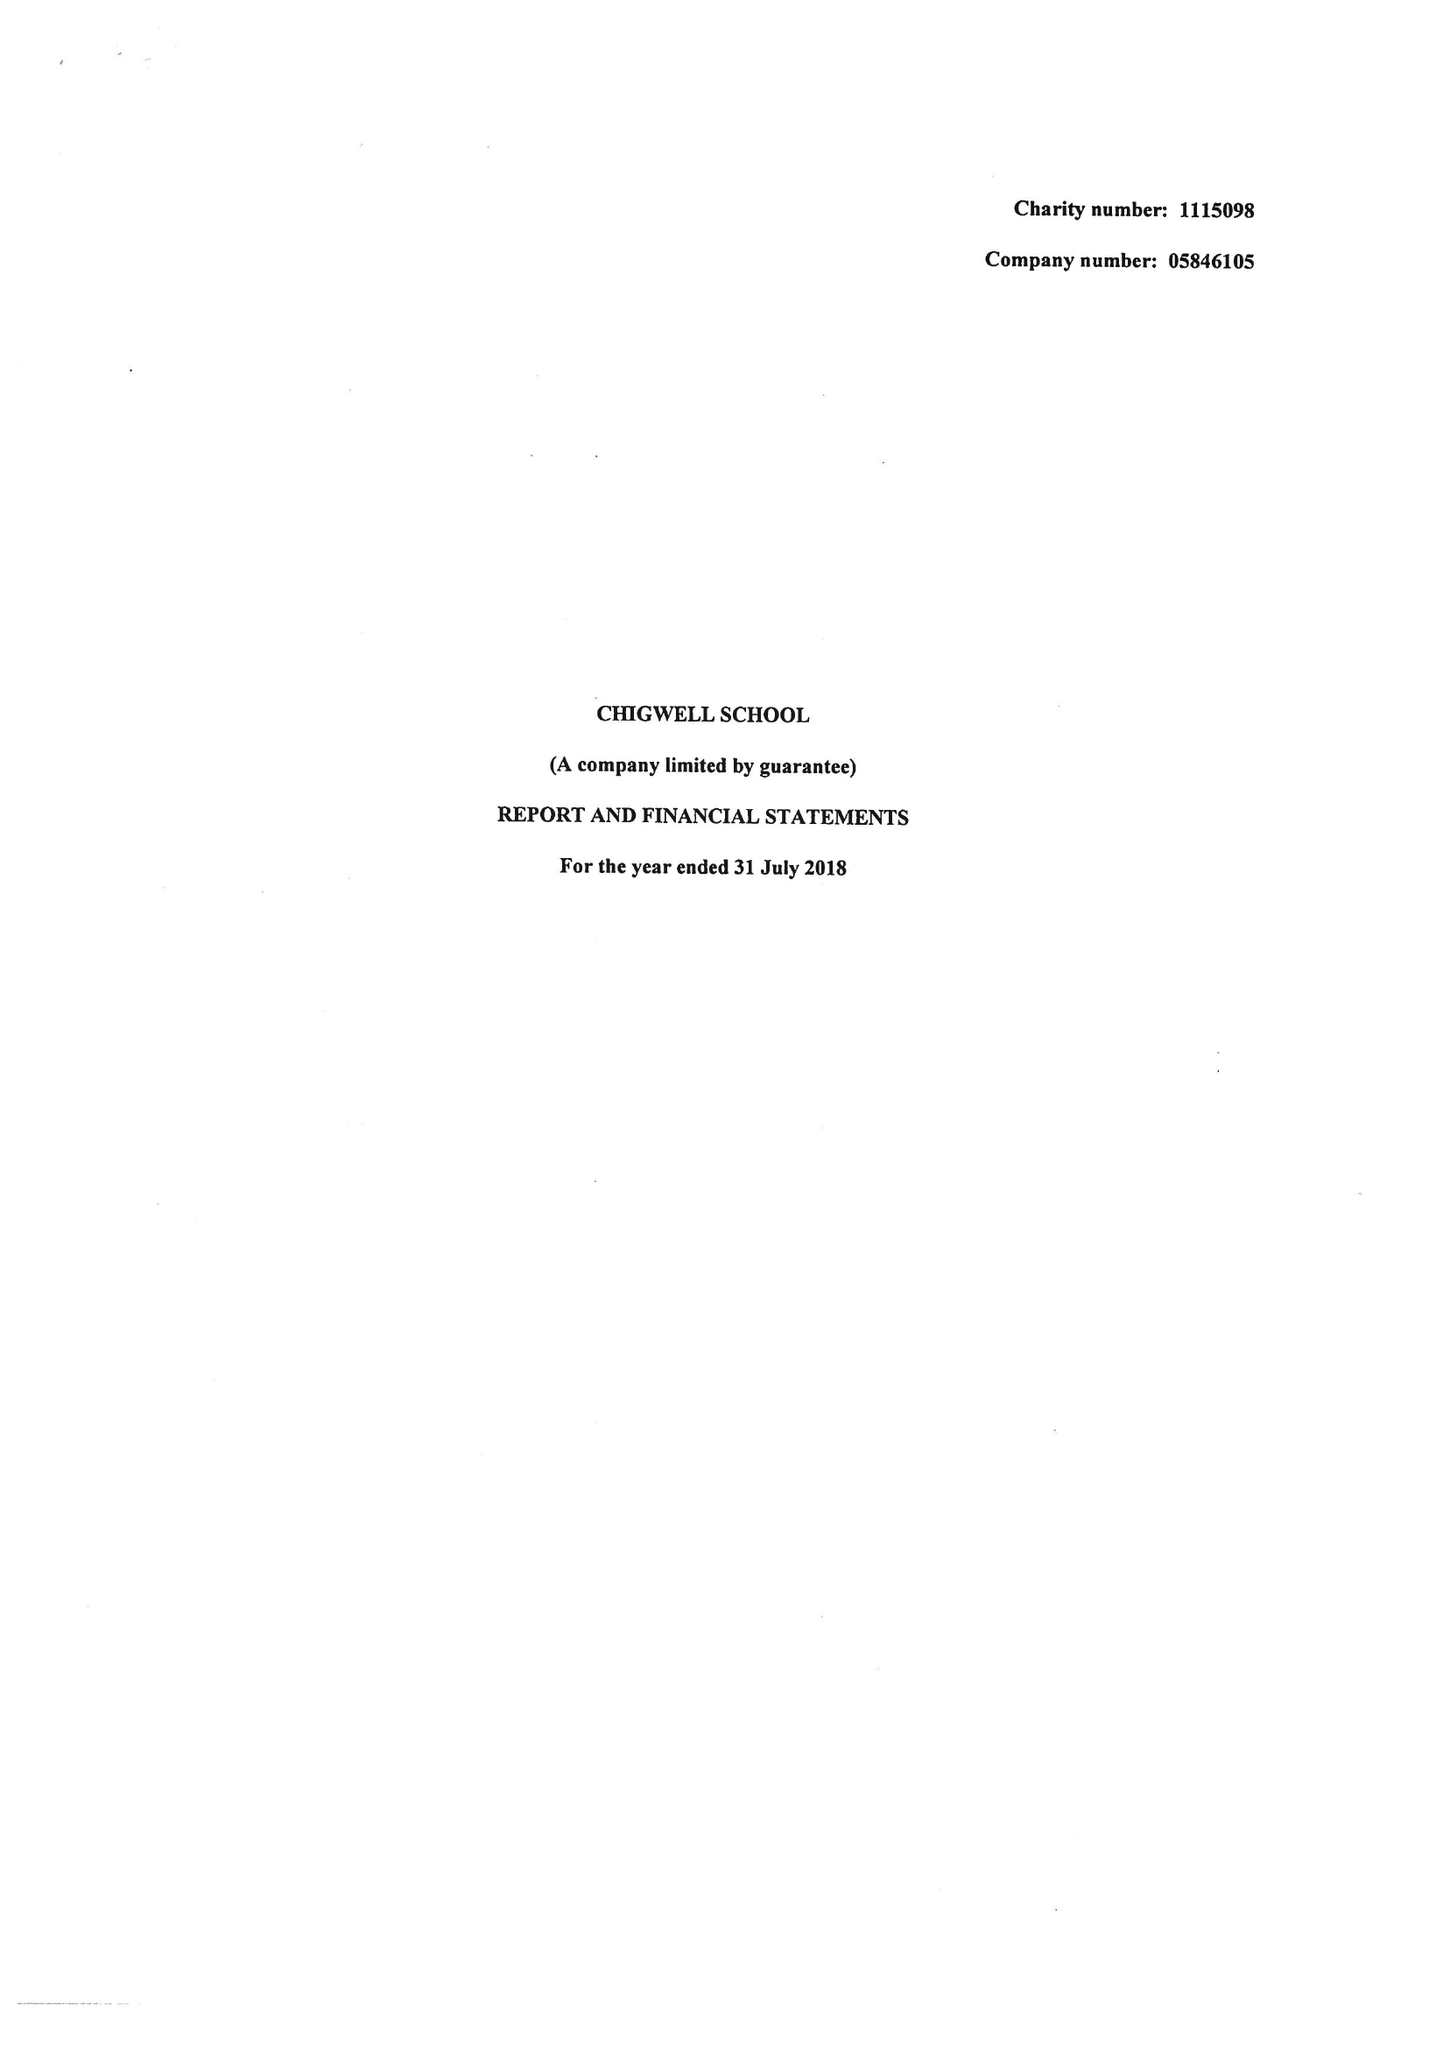What is the value for the spending_annually_in_british_pounds?
Answer the question using a single word or phrase. 13223274.00 